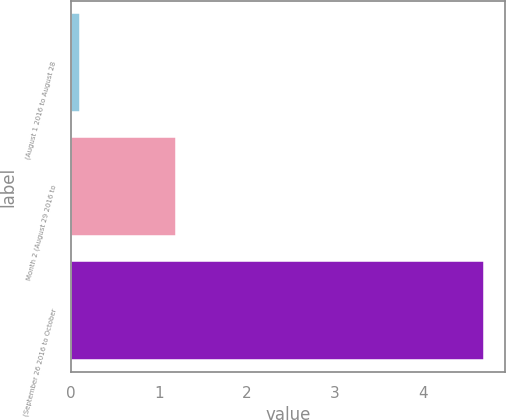<chart> <loc_0><loc_0><loc_500><loc_500><bar_chart><fcel>(August 1 2016 to August 28<fcel>Month 2 (August 29 2016 to<fcel>(September 26 2016 to October<nl><fcel>0.1<fcel>1.2<fcel>4.7<nl></chart> 